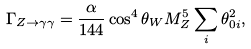<formula> <loc_0><loc_0><loc_500><loc_500>\Gamma _ { Z \to \gamma \gamma } = \frac { \alpha } { 1 4 4 } \cos ^ { 4 } \theta _ { W } M _ { Z } ^ { 5 } \sum _ { i } \theta _ { 0 i } ^ { 2 } ,</formula> 